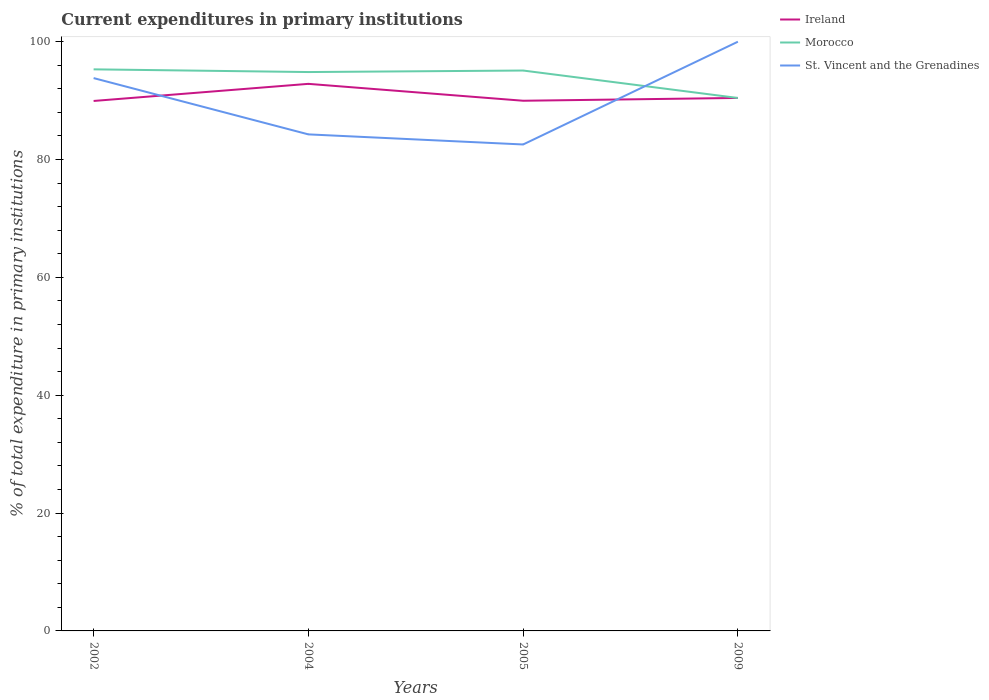Across all years, what is the maximum current expenditures in primary institutions in St. Vincent and the Grenadines?
Provide a short and direct response. 82.56. What is the total current expenditures in primary institutions in St. Vincent and the Grenadines in the graph?
Provide a succinct answer. 11.27. What is the difference between the highest and the second highest current expenditures in primary institutions in Morocco?
Your answer should be very brief. 4.86. What is the difference between the highest and the lowest current expenditures in primary institutions in St. Vincent and the Grenadines?
Make the answer very short. 2. How many lines are there?
Provide a succinct answer. 3. How many years are there in the graph?
Offer a very short reply. 4. What is the difference between two consecutive major ticks on the Y-axis?
Provide a short and direct response. 20. Does the graph contain grids?
Provide a succinct answer. No. What is the title of the graph?
Provide a short and direct response. Current expenditures in primary institutions. Does "Russian Federation" appear as one of the legend labels in the graph?
Your answer should be compact. No. What is the label or title of the X-axis?
Keep it short and to the point. Years. What is the label or title of the Y-axis?
Provide a short and direct response. % of total expenditure in primary institutions. What is the % of total expenditure in primary institutions of Ireland in 2002?
Offer a very short reply. 89.94. What is the % of total expenditure in primary institutions in Morocco in 2002?
Offer a very short reply. 95.31. What is the % of total expenditure in primary institutions in St. Vincent and the Grenadines in 2002?
Give a very brief answer. 93.83. What is the % of total expenditure in primary institutions of Ireland in 2004?
Your answer should be very brief. 92.85. What is the % of total expenditure in primary institutions of Morocco in 2004?
Keep it short and to the point. 94.85. What is the % of total expenditure in primary institutions of St. Vincent and the Grenadines in 2004?
Offer a terse response. 84.27. What is the % of total expenditure in primary institutions of Ireland in 2005?
Provide a short and direct response. 89.98. What is the % of total expenditure in primary institutions of Morocco in 2005?
Your answer should be very brief. 95.11. What is the % of total expenditure in primary institutions of St. Vincent and the Grenadines in 2005?
Provide a succinct answer. 82.56. What is the % of total expenditure in primary institutions in Ireland in 2009?
Provide a succinct answer. 90.46. What is the % of total expenditure in primary institutions in Morocco in 2009?
Your answer should be very brief. 90.45. What is the % of total expenditure in primary institutions in St. Vincent and the Grenadines in 2009?
Your answer should be very brief. 100. Across all years, what is the maximum % of total expenditure in primary institutions of Ireland?
Keep it short and to the point. 92.85. Across all years, what is the maximum % of total expenditure in primary institutions in Morocco?
Provide a succinct answer. 95.31. Across all years, what is the minimum % of total expenditure in primary institutions of Ireland?
Make the answer very short. 89.94. Across all years, what is the minimum % of total expenditure in primary institutions in Morocco?
Your answer should be very brief. 90.45. Across all years, what is the minimum % of total expenditure in primary institutions in St. Vincent and the Grenadines?
Your answer should be very brief. 82.56. What is the total % of total expenditure in primary institutions in Ireland in the graph?
Your answer should be very brief. 363.23. What is the total % of total expenditure in primary institutions of Morocco in the graph?
Your answer should be compact. 375.72. What is the total % of total expenditure in primary institutions of St. Vincent and the Grenadines in the graph?
Your response must be concise. 360.66. What is the difference between the % of total expenditure in primary institutions of Ireland in 2002 and that in 2004?
Offer a very short reply. -2.9. What is the difference between the % of total expenditure in primary institutions in Morocco in 2002 and that in 2004?
Offer a very short reply. 0.46. What is the difference between the % of total expenditure in primary institutions of St. Vincent and the Grenadines in 2002 and that in 2004?
Make the answer very short. 9.55. What is the difference between the % of total expenditure in primary institutions in Ireland in 2002 and that in 2005?
Provide a short and direct response. -0.04. What is the difference between the % of total expenditure in primary institutions in Morocco in 2002 and that in 2005?
Provide a succinct answer. 0.2. What is the difference between the % of total expenditure in primary institutions in St. Vincent and the Grenadines in 2002 and that in 2005?
Your response must be concise. 11.27. What is the difference between the % of total expenditure in primary institutions of Ireland in 2002 and that in 2009?
Provide a short and direct response. -0.51. What is the difference between the % of total expenditure in primary institutions in Morocco in 2002 and that in 2009?
Make the answer very short. 4.86. What is the difference between the % of total expenditure in primary institutions in St. Vincent and the Grenadines in 2002 and that in 2009?
Give a very brief answer. -6.17. What is the difference between the % of total expenditure in primary institutions of Ireland in 2004 and that in 2005?
Offer a very short reply. 2.87. What is the difference between the % of total expenditure in primary institutions in Morocco in 2004 and that in 2005?
Offer a very short reply. -0.26. What is the difference between the % of total expenditure in primary institutions in St. Vincent and the Grenadines in 2004 and that in 2005?
Your answer should be compact. 1.71. What is the difference between the % of total expenditure in primary institutions of Ireland in 2004 and that in 2009?
Your answer should be compact. 2.39. What is the difference between the % of total expenditure in primary institutions in Morocco in 2004 and that in 2009?
Give a very brief answer. 4.4. What is the difference between the % of total expenditure in primary institutions in St. Vincent and the Grenadines in 2004 and that in 2009?
Provide a succinct answer. -15.73. What is the difference between the % of total expenditure in primary institutions in Ireland in 2005 and that in 2009?
Offer a terse response. -0.47. What is the difference between the % of total expenditure in primary institutions of Morocco in 2005 and that in 2009?
Offer a terse response. 4.66. What is the difference between the % of total expenditure in primary institutions in St. Vincent and the Grenadines in 2005 and that in 2009?
Offer a terse response. -17.44. What is the difference between the % of total expenditure in primary institutions of Ireland in 2002 and the % of total expenditure in primary institutions of Morocco in 2004?
Provide a short and direct response. -4.91. What is the difference between the % of total expenditure in primary institutions in Ireland in 2002 and the % of total expenditure in primary institutions in St. Vincent and the Grenadines in 2004?
Provide a succinct answer. 5.67. What is the difference between the % of total expenditure in primary institutions in Morocco in 2002 and the % of total expenditure in primary institutions in St. Vincent and the Grenadines in 2004?
Your response must be concise. 11.04. What is the difference between the % of total expenditure in primary institutions in Ireland in 2002 and the % of total expenditure in primary institutions in Morocco in 2005?
Offer a terse response. -5.16. What is the difference between the % of total expenditure in primary institutions in Ireland in 2002 and the % of total expenditure in primary institutions in St. Vincent and the Grenadines in 2005?
Offer a very short reply. 7.39. What is the difference between the % of total expenditure in primary institutions of Morocco in 2002 and the % of total expenditure in primary institutions of St. Vincent and the Grenadines in 2005?
Ensure brevity in your answer.  12.75. What is the difference between the % of total expenditure in primary institutions of Ireland in 2002 and the % of total expenditure in primary institutions of Morocco in 2009?
Provide a succinct answer. -0.51. What is the difference between the % of total expenditure in primary institutions of Ireland in 2002 and the % of total expenditure in primary institutions of St. Vincent and the Grenadines in 2009?
Make the answer very short. -10.06. What is the difference between the % of total expenditure in primary institutions of Morocco in 2002 and the % of total expenditure in primary institutions of St. Vincent and the Grenadines in 2009?
Offer a terse response. -4.69. What is the difference between the % of total expenditure in primary institutions of Ireland in 2004 and the % of total expenditure in primary institutions of Morocco in 2005?
Your answer should be compact. -2.26. What is the difference between the % of total expenditure in primary institutions in Ireland in 2004 and the % of total expenditure in primary institutions in St. Vincent and the Grenadines in 2005?
Your answer should be very brief. 10.29. What is the difference between the % of total expenditure in primary institutions in Morocco in 2004 and the % of total expenditure in primary institutions in St. Vincent and the Grenadines in 2005?
Your answer should be compact. 12.29. What is the difference between the % of total expenditure in primary institutions of Ireland in 2004 and the % of total expenditure in primary institutions of Morocco in 2009?
Make the answer very short. 2.4. What is the difference between the % of total expenditure in primary institutions of Ireland in 2004 and the % of total expenditure in primary institutions of St. Vincent and the Grenadines in 2009?
Make the answer very short. -7.15. What is the difference between the % of total expenditure in primary institutions of Morocco in 2004 and the % of total expenditure in primary institutions of St. Vincent and the Grenadines in 2009?
Ensure brevity in your answer.  -5.15. What is the difference between the % of total expenditure in primary institutions of Ireland in 2005 and the % of total expenditure in primary institutions of Morocco in 2009?
Keep it short and to the point. -0.47. What is the difference between the % of total expenditure in primary institutions of Ireland in 2005 and the % of total expenditure in primary institutions of St. Vincent and the Grenadines in 2009?
Offer a terse response. -10.02. What is the difference between the % of total expenditure in primary institutions of Morocco in 2005 and the % of total expenditure in primary institutions of St. Vincent and the Grenadines in 2009?
Keep it short and to the point. -4.89. What is the average % of total expenditure in primary institutions in Ireland per year?
Offer a terse response. 90.81. What is the average % of total expenditure in primary institutions of Morocco per year?
Provide a short and direct response. 93.93. What is the average % of total expenditure in primary institutions of St. Vincent and the Grenadines per year?
Keep it short and to the point. 90.16. In the year 2002, what is the difference between the % of total expenditure in primary institutions in Ireland and % of total expenditure in primary institutions in Morocco?
Offer a terse response. -5.36. In the year 2002, what is the difference between the % of total expenditure in primary institutions in Ireland and % of total expenditure in primary institutions in St. Vincent and the Grenadines?
Ensure brevity in your answer.  -3.88. In the year 2002, what is the difference between the % of total expenditure in primary institutions of Morocco and % of total expenditure in primary institutions of St. Vincent and the Grenadines?
Provide a short and direct response. 1.48. In the year 2004, what is the difference between the % of total expenditure in primary institutions of Ireland and % of total expenditure in primary institutions of Morocco?
Keep it short and to the point. -2. In the year 2004, what is the difference between the % of total expenditure in primary institutions of Ireland and % of total expenditure in primary institutions of St. Vincent and the Grenadines?
Your answer should be very brief. 8.58. In the year 2004, what is the difference between the % of total expenditure in primary institutions of Morocco and % of total expenditure in primary institutions of St. Vincent and the Grenadines?
Provide a short and direct response. 10.58. In the year 2005, what is the difference between the % of total expenditure in primary institutions of Ireland and % of total expenditure in primary institutions of Morocco?
Offer a very short reply. -5.13. In the year 2005, what is the difference between the % of total expenditure in primary institutions in Ireland and % of total expenditure in primary institutions in St. Vincent and the Grenadines?
Offer a terse response. 7.42. In the year 2005, what is the difference between the % of total expenditure in primary institutions of Morocco and % of total expenditure in primary institutions of St. Vincent and the Grenadines?
Give a very brief answer. 12.55. In the year 2009, what is the difference between the % of total expenditure in primary institutions of Ireland and % of total expenditure in primary institutions of Morocco?
Keep it short and to the point. 0.01. In the year 2009, what is the difference between the % of total expenditure in primary institutions in Ireland and % of total expenditure in primary institutions in St. Vincent and the Grenadines?
Provide a short and direct response. -9.54. In the year 2009, what is the difference between the % of total expenditure in primary institutions in Morocco and % of total expenditure in primary institutions in St. Vincent and the Grenadines?
Offer a terse response. -9.55. What is the ratio of the % of total expenditure in primary institutions in Ireland in 2002 to that in 2004?
Provide a succinct answer. 0.97. What is the ratio of the % of total expenditure in primary institutions in Morocco in 2002 to that in 2004?
Your answer should be very brief. 1. What is the ratio of the % of total expenditure in primary institutions in St. Vincent and the Grenadines in 2002 to that in 2004?
Make the answer very short. 1.11. What is the ratio of the % of total expenditure in primary institutions of Ireland in 2002 to that in 2005?
Keep it short and to the point. 1. What is the ratio of the % of total expenditure in primary institutions in Morocco in 2002 to that in 2005?
Your answer should be compact. 1. What is the ratio of the % of total expenditure in primary institutions of St. Vincent and the Grenadines in 2002 to that in 2005?
Keep it short and to the point. 1.14. What is the ratio of the % of total expenditure in primary institutions in Ireland in 2002 to that in 2009?
Give a very brief answer. 0.99. What is the ratio of the % of total expenditure in primary institutions in Morocco in 2002 to that in 2009?
Provide a short and direct response. 1.05. What is the ratio of the % of total expenditure in primary institutions of St. Vincent and the Grenadines in 2002 to that in 2009?
Provide a succinct answer. 0.94. What is the ratio of the % of total expenditure in primary institutions in Ireland in 2004 to that in 2005?
Offer a very short reply. 1.03. What is the ratio of the % of total expenditure in primary institutions in St. Vincent and the Grenadines in 2004 to that in 2005?
Provide a short and direct response. 1.02. What is the ratio of the % of total expenditure in primary institutions in Ireland in 2004 to that in 2009?
Provide a short and direct response. 1.03. What is the ratio of the % of total expenditure in primary institutions in Morocco in 2004 to that in 2009?
Offer a very short reply. 1.05. What is the ratio of the % of total expenditure in primary institutions of St. Vincent and the Grenadines in 2004 to that in 2009?
Make the answer very short. 0.84. What is the ratio of the % of total expenditure in primary institutions in Ireland in 2005 to that in 2009?
Your response must be concise. 0.99. What is the ratio of the % of total expenditure in primary institutions of Morocco in 2005 to that in 2009?
Offer a terse response. 1.05. What is the ratio of the % of total expenditure in primary institutions in St. Vincent and the Grenadines in 2005 to that in 2009?
Your answer should be very brief. 0.83. What is the difference between the highest and the second highest % of total expenditure in primary institutions of Ireland?
Ensure brevity in your answer.  2.39. What is the difference between the highest and the second highest % of total expenditure in primary institutions in Morocco?
Offer a very short reply. 0.2. What is the difference between the highest and the second highest % of total expenditure in primary institutions in St. Vincent and the Grenadines?
Your answer should be compact. 6.17. What is the difference between the highest and the lowest % of total expenditure in primary institutions in Ireland?
Make the answer very short. 2.9. What is the difference between the highest and the lowest % of total expenditure in primary institutions of Morocco?
Offer a terse response. 4.86. What is the difference between the highest and the lowest % of total expenditure in primary institutions of St. Vincent and the Grenadines?
Your answer should be very brief. 17.44. 